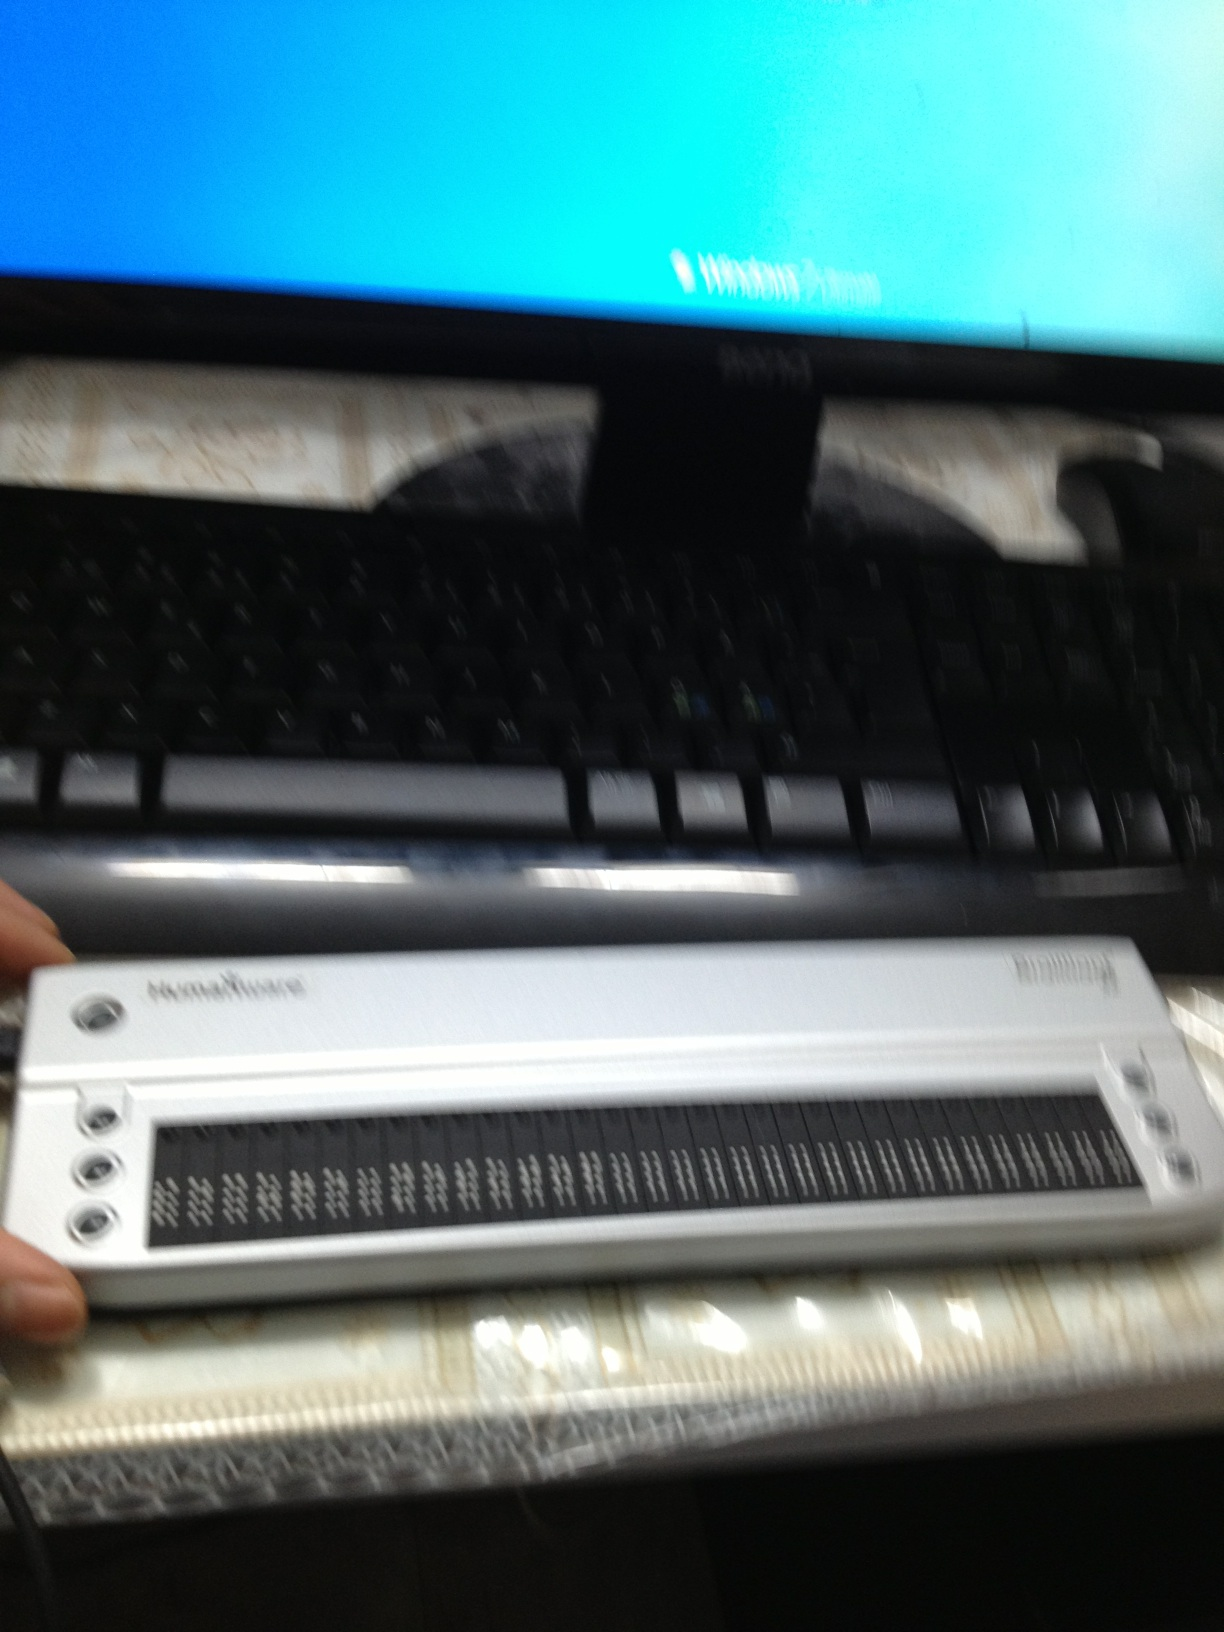If this image were part of a futuristic sci-fi movie, what role could the refreshable braille display play? In a futuristic sci-fi movie, the refreshable braille display could be an advanced communication device that allows humans to interact with alien technology. Through this interface, visually impaired users might be able to decode alien symbols and messages, playing a crucial role in deciphering interstellar communications and saving the world from extraterrestrial threats. 